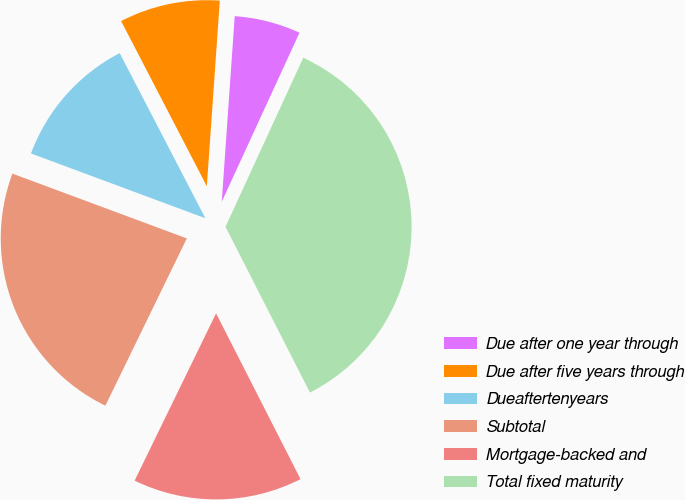<chart> <loc_0><loc_0><loc_500><loc_500><pie_chart><fcel>Due after one year through<fcel>Due after five years through<fcel>Dueaftertenyears<fcel>Subtotal<fcel>Mortgage-backed and<fcel>Total fixed maturity<nl><fcel>5.75%<fcel>8.73%<fcel>11.72%<fcel>23.45%<fcel>14.71%<fcel>35.64%<nl></chart> 